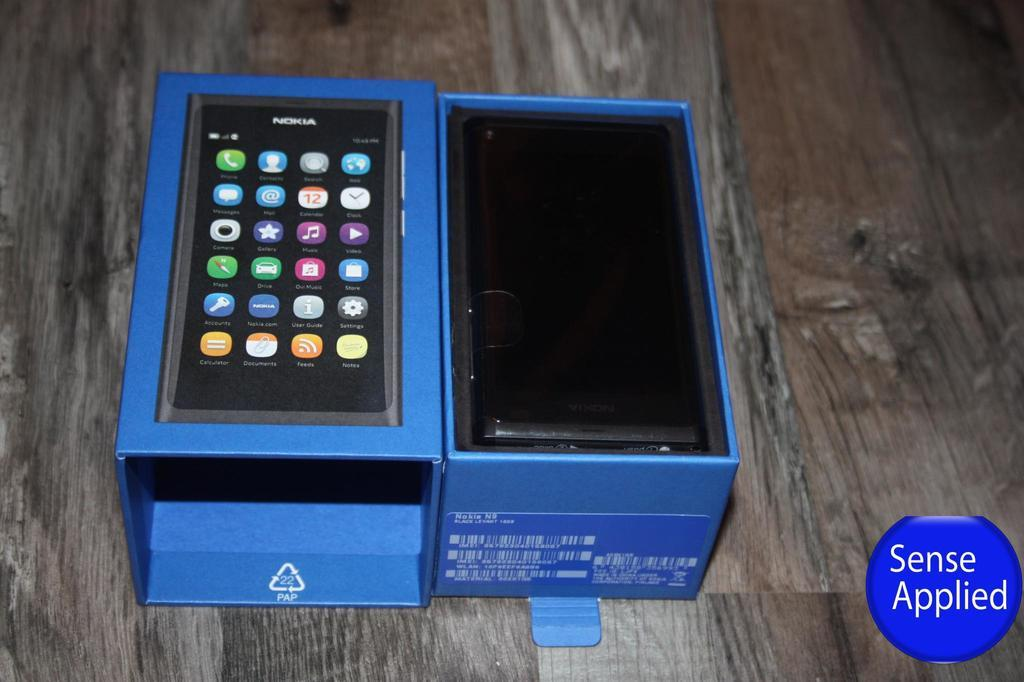<image>
Write a terse but informative summary of the picture. Two blue boxes next to one another that are for Nokia phones. 